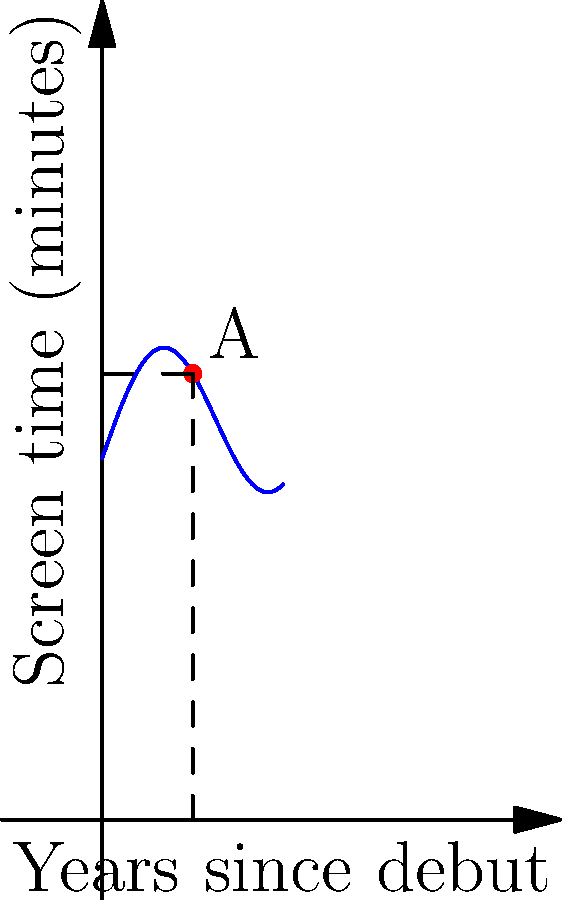The graph represents Tahar Rahim's screen time in minutes (y-axis) over the years since his debut (x-axis). At point A, which occurs 5 years after his debut, what is the instantaneous rate of change of his screen time? To find the instantaneous rate of change at point A, we need to calculate the derivative of the function at x = 5. The steps are:

1) The function appears to be of the form $f(x) = 20 + 5\sin(\frac{x}{2}) + \frac{x}{3}$

2) The derivative of this function is:
   $f'(x) = 5 \cdot \frac{1}{2} \cos(\frac{x}{2}) + \frac{1}{3}$
   
3) At x = 5:
   $f'(5) = 5 \cdot \frac{1}{2} \cos(\frac{5}{2}) + \frac{1}{3}$
   
4) Simplifying:
   $f'(5) = \frac{5}{2} \cos(2.5) + \frac{1}{3}$
   
5) Using a calculator:
   $f'(5) \approx -0.7145 + 0.3333 \approx -0.3812$

Therefore, the instantaneous rate of change at point A is approximately -0.3812 minutes per year.
Answer: $-0.3812$ minutes/year 